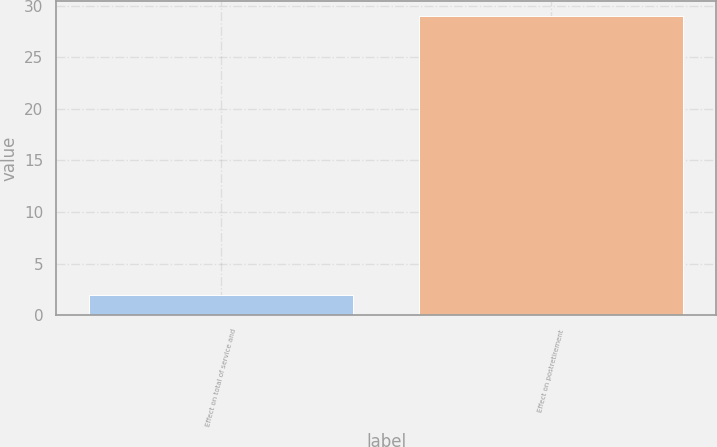Convert chart to OTSL. <chart><loc_0><loc_0><loc_500><loc_500><bar_chart><fcel>Effect on total of service and<fcel>Effect on postretirement<nl><fcel>2<fcel>29<nl></chart> 